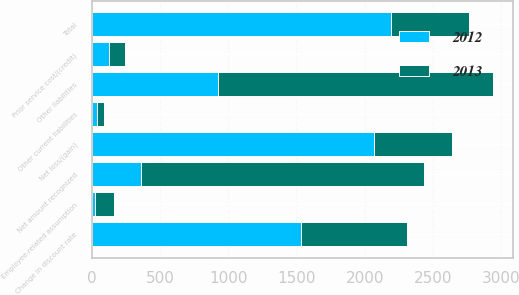Convert chart. <chart><loc_0><loc_0><loc_500><loc_500><stacked_bar_chart><ecel><fcel>Other current liabilities<fcel>Other liabilities<fcel>Net amount recognized<fcel>Net loss/(gain)<fcel>Prior service cost/(credit)<fcel>Total<fcel>Change in discount rate<fcel>Employee-related assumption<nl><fcel>2012<fcel>41<fcel>925<fcel>363<fcel>2069<fcel>125<fcel>2194<fcel>1532<fcel>24<nl><fcel>2013<fcel>51<fcel>2018<fcel>2069<fcel>569.5<fcel>121<fcel>569.5<fcel>776<fcel>135<nl></chart> 